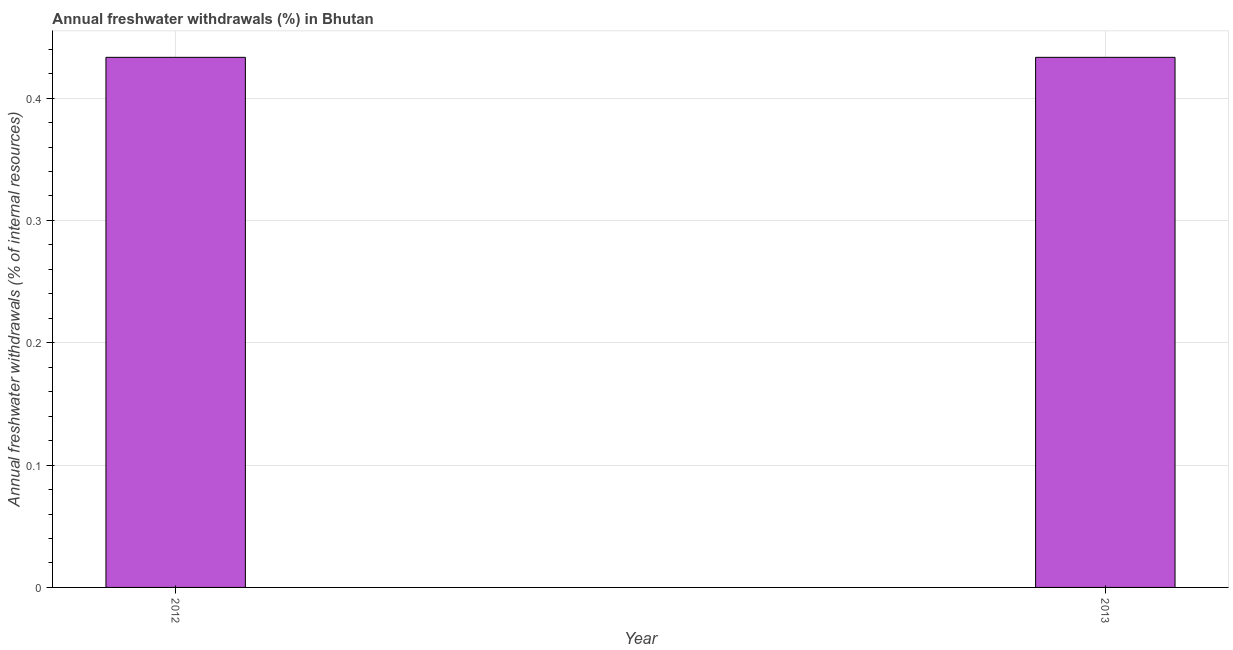What is the title of the graph?
Make the answer very short. Annual freshwater withdrawals (%) in Bhutan. What is the label or title of the X-axis?
Your answer should be compact. Year. What is the label or title of the Y-axis?
Make the answer very short. Annual freshwater withdrawals (% of internal resources). What is the annual freshwater withdrawals in 2013?
Offer a very short reply. 0.43. Across all years, what is the maximum annual freshwater withdrawals?
Provide a short and direct response. 0.43. Across all years, what is the minimum annual freshwater withdrawals?
Ensure brevity in your answer.  0.43. In which year was the annual freshwater withdrawals maximum?
Offer a very short reply. 2012. What is the sum of the annual freshwater withdrawals?
Provide a short and direct response. 0.87. What is the difference between the annual freshwater withdrawals in 2012 and 2013?
Your response must be concise. 0. What is the average annual freshwater withdrawals per year?
Your answer should be compact. 0.43. What is the median annual freshwater withdrawals?
Offer a terse response. 0.43. Do a majority of the years between 2013 and 2012 (inclusive) have annual freshwater withdrawals greater than 0.38 %?
Give a very brief answer. No. What is the ratio of the annual freshwater withdrawals in 2012 to that in 2013?
Provide a succinct answer. 1. Is the annual freshwater withdrawals in 2012 less than that in 2013?
Your response must be concise. No. How many years are there in the graph?
Your answer should be compact. 2. What is the difference between two consecutive major ticks on the Y-axis?
Your answer should be compact. 0.1. Are the values on the major ticks of Y-axis written in scientific E-notation?
Offer a terse response. No. What is the Annual freshwater withdrawals (% of internal resources) in 2012?
Make the answer very short. 0.43. What is the Annual freshwater withdrawals (% of internal resources) of 2013?
Make the answer very short. 0.43. What is the difference between the Annual freshwater withdrawals (% of internal resources) in 2012 and 2013?
Give a very brief answer. 0. What is the ratio of the Annual freshwater withdrawals (% of internal resources) in 2012 to that in 2013?
Offer a very short reply. 1. 